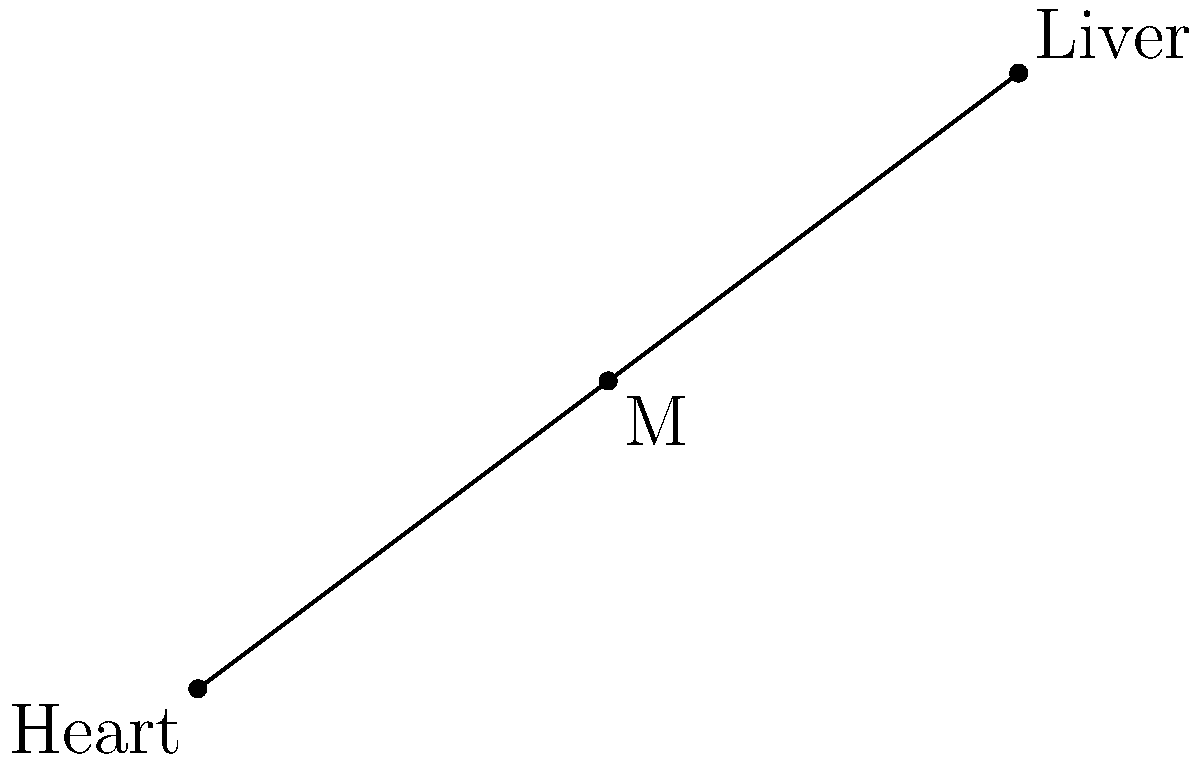In a simplified human body diagram, the heart is located at coordinates (0,0) and the liver at (8,6) on a Cartesian plane. Find the coordinates of the midpoint of the line segment connecting these two organs. To find the midpoint of a line segment, we can use the midpoint formula:

$$ M_x = \frac{x_1 + x_2}{2}, \quad M_y = \frac{y_1 + y_2}{2} $$

Where $(x_1, y_1)$ are the coordinates of the first point (heart) and $(x_2, y_2)$ are the coordinates of the second point (liver).

Step 1: Identify the coordinates
Heart: $(x_1, y_1) = (0, 0)$
Liver: $(x_2, y_2) = (8, 6)$

Step 2: Calculate the x-coordinate of the midpoint
$$ M_x = \frac{x_1 + x_2}{2} = \frac{0 + 8}{2} = \frac{8}{2} = 4 $$

Step 3: Calculate the y-coordinate of the midpoint
$$ M_y = \frac{y_1 + y_2}{2} = \frac{0 + 6}{2} = \frac{6}{2} = 3 $$

Step 4: Combine the results
The midpoint coordinates are $(M_x, M_y) = (4, 3)$
Answer: $(4, 3)$ 